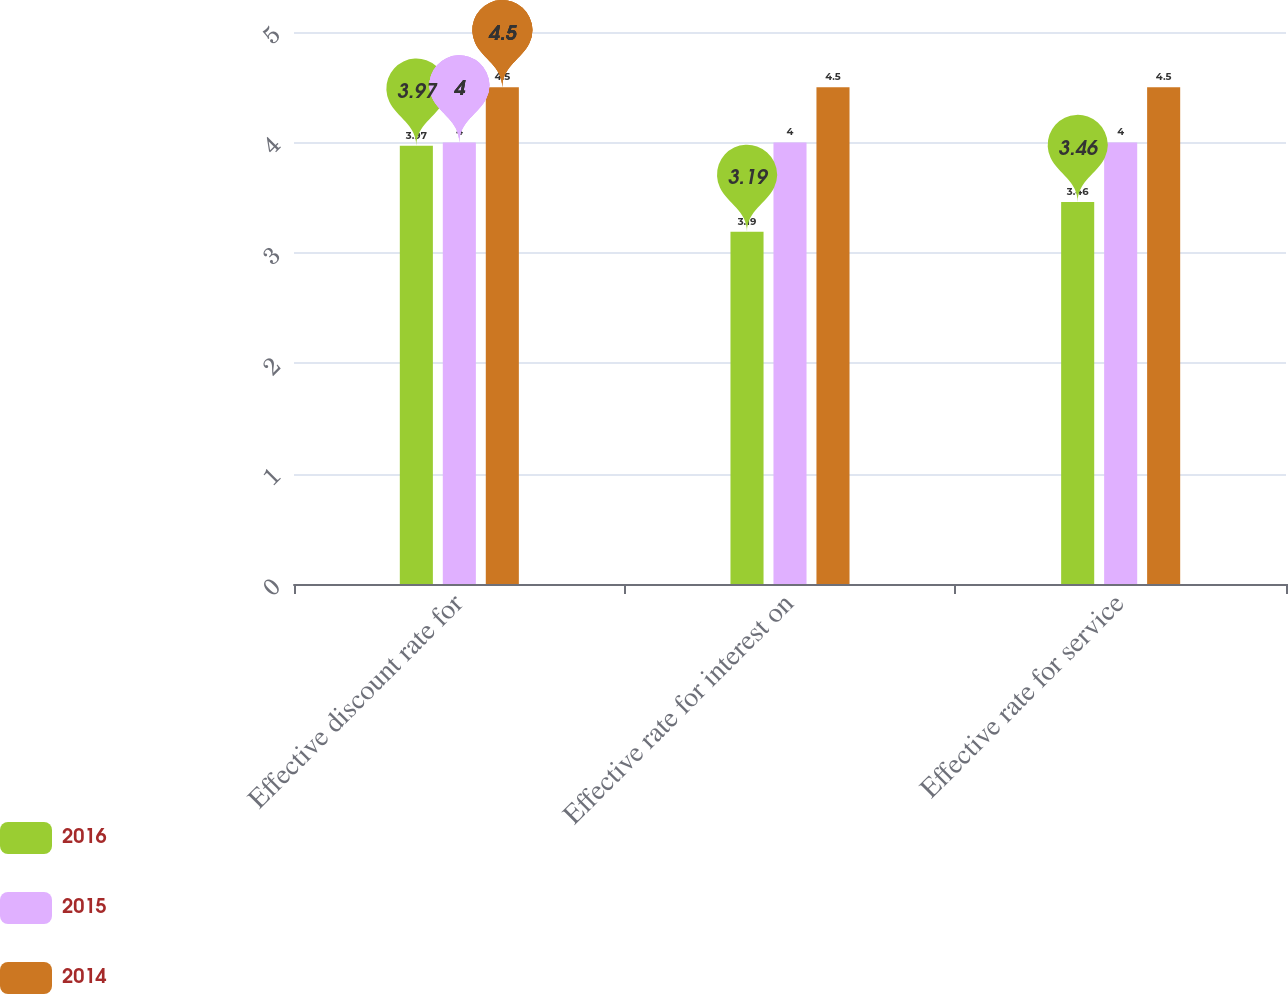<chart> <loc_0><loc_0><loc_500><loc_500><stacked_bar_chart><ecel><fcel>Effective discount rate for<fcel>Effective rate for interest on<fcel>Effective rate for service<nl><fcel>2016<fcel>3.97<fcel>3.19<fcel>3.46<nl><fcel>2015<fcel>4<fcel>4<fcel>4<nl><fcel>2014<fcel>4.5<fcel>4.5<fcel>4.5<nl></chart> 